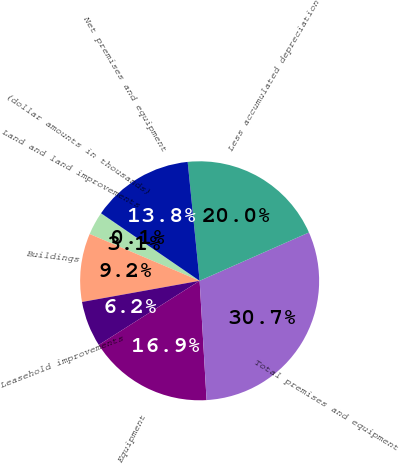Convert chart to OTSL. <chart><loc_0><loc_0><loc_500><loc_500><pie_chart><fcel>(dollar amounts in thousands)<fcel>Land and land improvements<fcel>Buildings<fcel>Leasehold improvements<fcel>Equipment<fcel>Total premises and equipment<fcel>Less accumulated depreciation<fcel>Net premises and equipment<nl><fcel>0.05%<fcel>3.11%<fcel>9.24%<fcel>6.18%<fcel>16.91%<fcel>30.7%<fcel>19.97%<fcel>13.84%<nl></chart> 